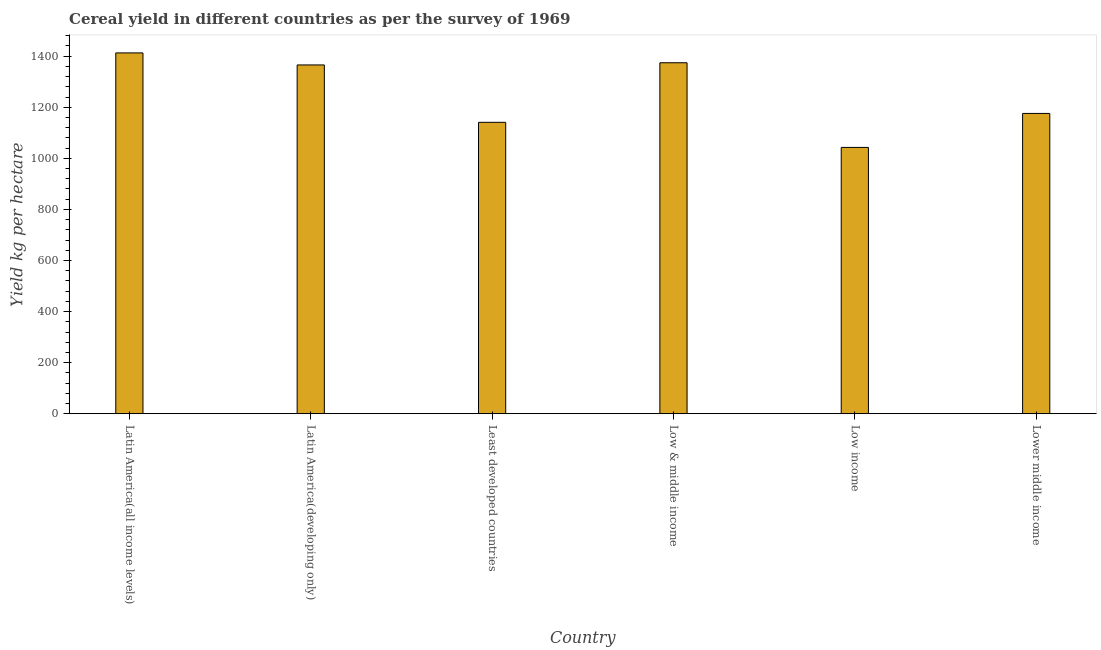What is the title of the graph?
Give a very brief answer. Cereal yield in different countries as per the survey of 1969. What is the label or title of the X-axis?
Provide a succinct answer. Country. What is the label or title of the Y-axis?
Provide a short and direct response. Yield kg per hectare. What is the cereal yield in Least developed countries?
Make the answer very short. 1140.98. Across all countries, what is the maximum cereal yield?
Your answer should be compact. 1412.74. Across all countries, what is the minimum cereal yield?
Offer a very short reply. 1042.77. In which country was the cereal yield maximum?
Provide a short and direct response. Latin America(all income levels). In which country was the cereal yield minimum?
Provide a short and direct response. Low income. What is the sum of the cereal yield?
Ensure brevity in your answer.  7512.12. What is the difference between the cereal yield in Latin America(all income levels) and Low income?
Provide a succinct answer. 369.97. What is the average cereal yield per country?
Provide a short and direct response. 1252.02. What is the median cereal yield?
Provide a succinct answer. 1270.71. In how many countries, is the cereal yield greater than 960 kg per hectare?
Keep it short and to the point. 6. What is the ratio of the cereal yield in Low & middle income to that in Lower middle income?
Make the answer very short. 1.17. What is the difference between the highest and the second highest cereal yield?
Offer a terse response. 38.54. Is the sum of the cereal yield in Least developed countries and Low income greater than the maximum cereal yield across all countries?
Your response must be concise. Yes. What is the difference between the highest and the lowest cereal yield?
Your answer should be compact. 369.97. In how many countries, is the cereal yield greater than the average cereal yield taken over all countries?
Give a very brief answer. 3. How many bars are there?
Offer a terse response. 6. How many countries are there in the graph?
Ensure brevity in your answer.  6. Are the values on the major ticks of Y-axis written in scientific E-notation?
Make the answer very short. No. What is the Yield kg per hectare of Latin America(all income levels)?
Your response must be concise. 1412.74. What is the Yield kg per hectare in Latin America(developing only)?
Your response must be concise. 1365.63. What is the Yield kg per hectare of Least developed countries?
Provide a succinct answer. 1140.98. What is the Yield kg per hectare in Low & middle income?
Ensure brevity in your answer.  1374.2. What is the Yield kg per hectare of Low income?
Your answer should be compact. 1042.77. What is the Yield kg per hectare in Lower middle income?
Ensure brevity in your answer.  1175.79. What is the difference between the Yield kg per hectare in Latin America(all income levels) and Latin America(developing only)?
Ensure brevity in your answer.  47.11. What is the difference between the Yield kg per hectare in Latin America(all income levels) and Least developed countries?
Offer a terse response. 271.76. What is the difference between the Yield kg per hectare in Latin America(all income levels) and Low & middle income?
Your answer should be compact. 38.54. What is the difference between the Yield kg per hectare in Latin America(all income levels) and Low income?
Give a very brief answer. 369.97. What is the difference between the Yield kg per hectare in Latin America(all income levels) and Lower middle income?
Provide a succinct answer. 236.96. What is the difference between the Yield kg per hectare in Latin America(developing only) and Least developed countries?
Give a very brief answer. 224.65. What is the difference between the Yield kg per hectare in Latin America(developing only) and Low & middle income?
Provide a succinct answer. -8.57. What is the difference between the Yield kg per hectare in Latin America(developing only) and Low income?
Make the answer very short. 322.86. What is the difference between the Yield kg per hectare in Latin America(developing only) and Lower middle income?
Offer a very short reply. 189.84. What is the difference between the Yield kg per hectare in Least developed countries and Low & middle income?
Your response must be concise. -233.22. What is the difference between the Yield kg per hectare in Least developed countries and Low income?
Make the answer very short. 98.21. What is the difference between the Yield kg per hectare in Least developed countries and Lower middle income?
Provide a succinct answer. -34.81. What is the difference between the Yield kg per hectare in Low & middle income and Low income?
Your answer should be very brief. 331.43. What is the difference between the Yield kg per hectare in Low & middle income and Lower middle income?
Make the answer very short. 198.41. What is the difference between the Yield kg per hectare in Low income and Lower middle income?
Give a very brief answer. -133.02. What is the ratio of the Yield kg per hectare in Latin America(all income levels) to that in Latin America(developing only)?
Your answer should be compact. 1.03. What is the ratio of the Yield kg per hectare in Latin America(all income levels) to that in Least developed countries?
Your answer should be compact. 1.24. What is the ratio of the Yield kg per hectare in Latin America(all income levels) to that in Low & middle income?
Provide a short and direct response. 1.03. What is the ratio of the Yield kg per hectare in Latin America(all income levels) to that in Low income?
Make the answer very short. 1.35. What is the ratio of the Yield kg per hectare in Latin America(all income levels) to that in Lower middle income?
Provide a short and direct response. 1.2. What is the ratio of the Yield kg per hectare in Latin America(developing only) to that in Least developed countries?
Your answer should be compact. 1.2. What is the ratio of the Yield kg per hectare in Latin America(developing only) to that in Low & middle income?
Offer a very short reply. 0.99. What is the ratio of the Yield kg per hectare in Latin America(developing only) to that in Low income?
Offer a very short reply. 1.31. What is the ratio of the Yield kg per hectare in Latin America(developing only) to that in Lower middle income?
Make the answer very short. 1.16. What is the ratio of the Yield kg per hectare in Least developed countries to that in Low & middle income?
Your answer should be very brief. 0.83. What is the ratio of the Yield kg per hectare in Least developed countries to that in Low income?
Give a very brief answer. 1.09. What is the ratio of the Yield kg per hectare in Least developed countries to that in Lower middle income?
Provide a short and direct response. 0.97. What is the ratio of the Yield kg per hectare in Low & middle income to that in Low income?
Provide a short and direct response. 1.32. What is the ratio of the Yield kg per hectare in Low & middle income to that in Lower middle income?
Ensure brevity in your answer.  1.17. What is the ratio of the Yield kg per hectare in Low income to that in Lower middle income?
Give a very brief answer. 0.89. 